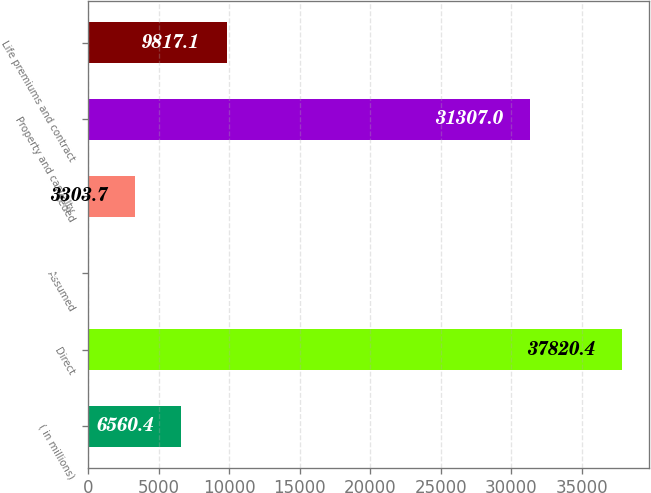Convert chart. <chart><loc_0><loc_0><loc_500><loc_500><bar_chart><fcel>( in millions)<fcel>Direct<fcel>Assumed<fcel>Ceded<fcel>Property and casualty<fcel>Life premiums and contract<nl><fcel>6560.4<fcel>37820.4<fcel>47<fcel>3303.7<fcel>31307<fcel>9817.1<nl></chart> 